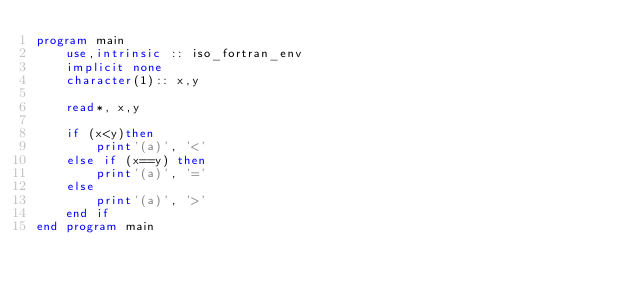<code> <loc_0><loc_0><loc_500><loc_500><_FORTRAN_>program main
    use,intrinsic :: iso_fortran_env
    implicit none
    character(1):: x,y

    read*, x,y

    if (x<y)then
        print'(a)', '<'
    else if (x==y) then
        print'(a)', '='
    else
        print'(a)', '>'
    end if
end program main</code> 